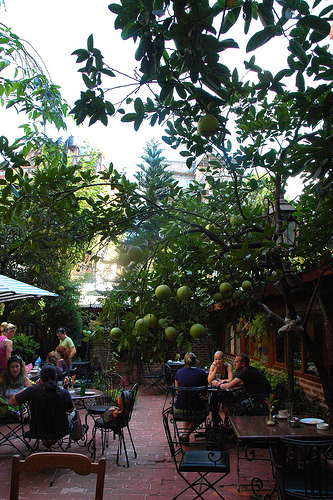<image>
Is the tree on the window? No. The tree is not positioned on the window. They may be near each other, but the tree is not supported by or resting on top of the window. 